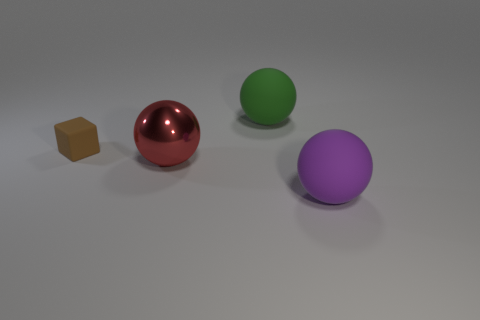Is there anything else that has the same material as the big red ball?
Your answer should be compact. No. There is a large rubber thing left of the matte sphere in front of the large rubber thing that is behind the purple ball; what shape is it?
Ensure brevity in your answer.  Sphere. Are there more large matte spheres left of the big red ball than big brown balls?
Offer a very short reply. No. Are there any other things of the same shape as the large red metal object?
Provide a short and direct response. Yes. Is the material of the large purple thing the same as the big object that is behind the red ball?
Your answer should be very brief. Yes. What is the color of the large metallic sphere?
Ensure brevity in your answer.  Red. There is a rubber object that is to the left of the matte ball behind the red ball; how many tiny rubber objects are to the right of it?
Provide a short and direct response. 0. Are there any small matte objects left of the brown thing?
Provide a succinct answer. No. What number of green objects have the same material as the red sphere?
Offer a terse response. 0. What number of things are either yellow objects or small brown rubber things?
Ensure brevity in your answer.  1. 